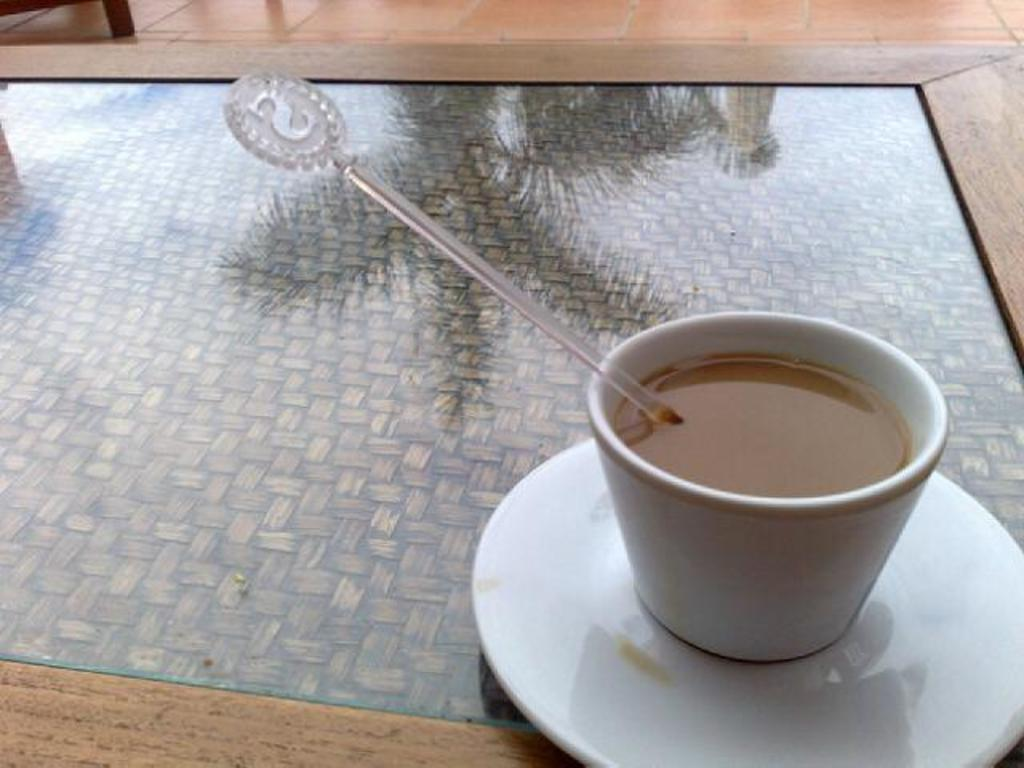What piece of furniture is present in the image? There is a table in the image. What is on the table? There is a cup with tea and a saucer on the table. What else can be seen on the table? There is a stick on the table. What can be seen in the background of the image? The background of the image includes the floor and table legs. What type of request can be seen written on the list in the image? There is no list present in the image, so it is not possible to answer that question. 